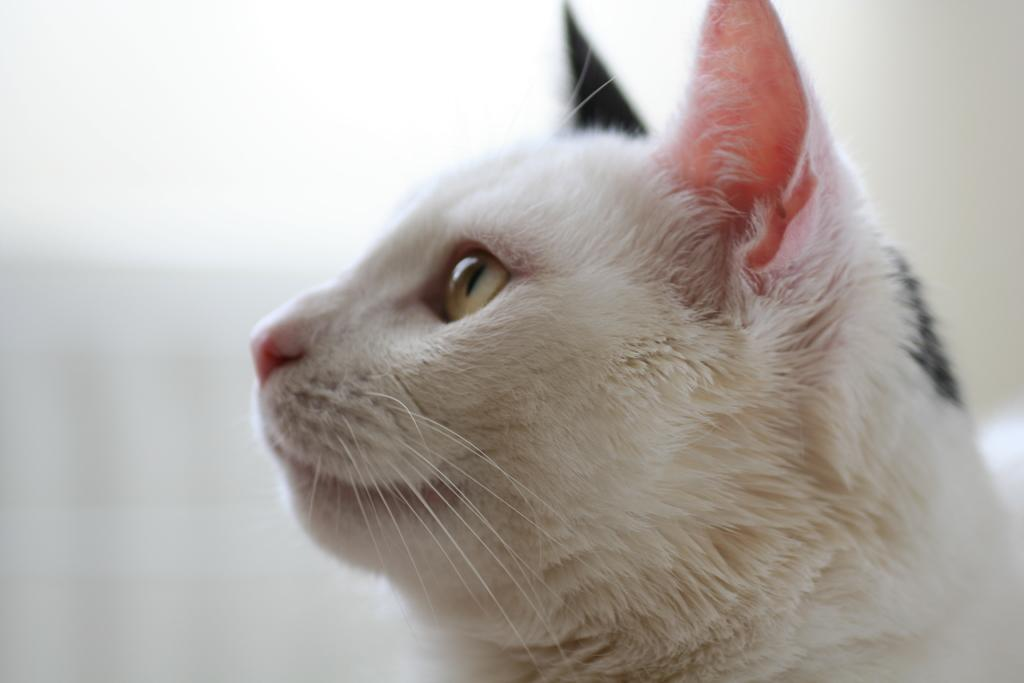What animal is the main subject of the picture? There is a cat in the picture. Can you describe the background of the image? The background of the image is blurred. How does the cat compare to the fowl in the image? There is no fowl present in the image, so it cannot be compared to the cat. What is the condition of the cat's knee in the image? There is no indication of the cat's knee in the image, as it is not visible or mentioned in the provided facts. 